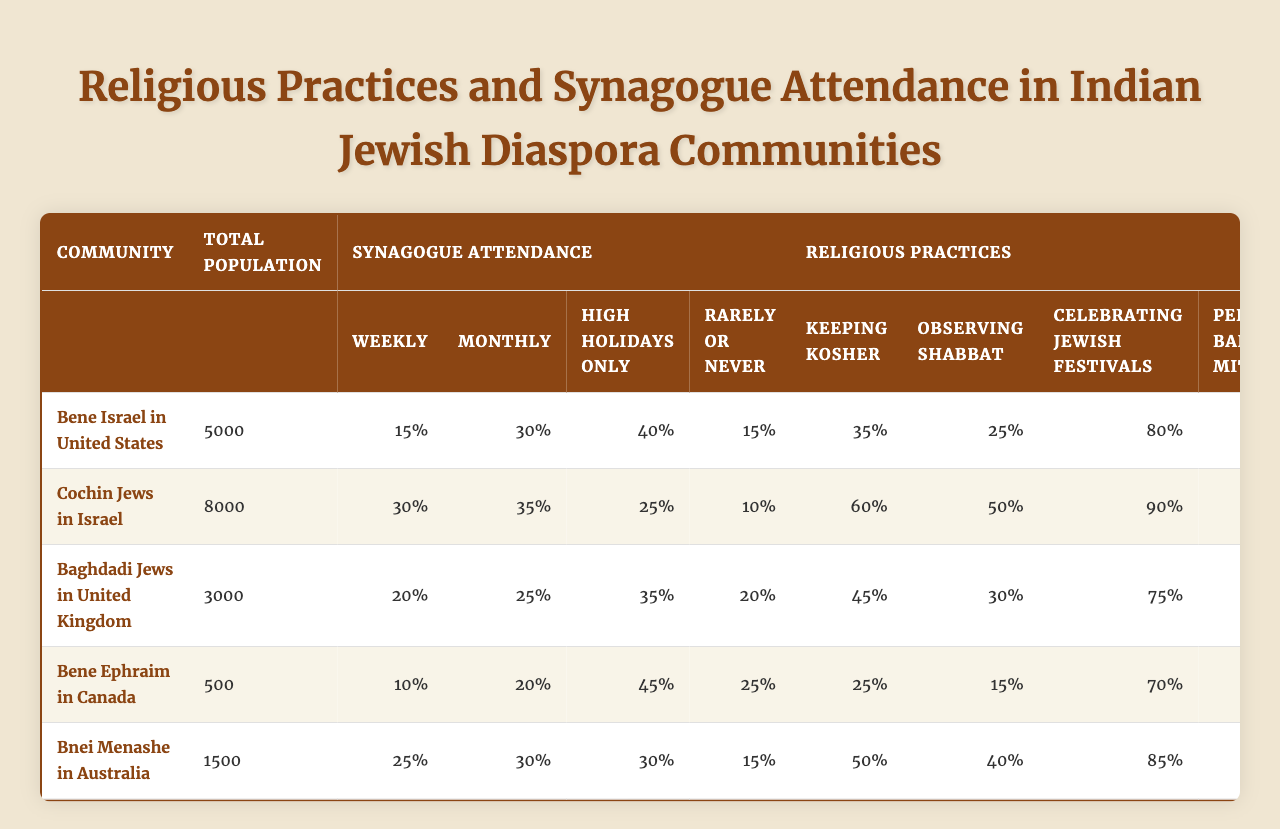What percentage of the Bene Israel community in the US attends synagogue weekly? The table shows that 15% of the Bene Israel community in the United States attends synagogue weekly.
Answer: 15% Which community has the highest percentage of individuals keeping kosher? Among the communities listed, the Cochin Jews in Israel have the highest percentage of individuals keeping kosher, which is 60%.
Answer: 60% What is the combined percentage of the Bnei Menashe community in Australia that attends synagogue weekly or monthly? To find the combined percentage, add the weekly (25%) and monthly (30%) attendance rates: 25% + 30% = 55%.
Answer: 55% Do the Bene Ephraim in Canada have a higher rate of observing Shabbat than the Baghdadi Jews in the UK? The rate of observing Shabbat among the Bene Ephraim is 15%, while it is 30% for the Baghdadi Jews. Therefore, the Bene Ephraim do not have a higher rate of observing Shabbat.
Answer: No What community has the lowest total population, and what is their synagogue attendance rate for High Holidays only? The Bene Ephraim in Canada have the lowest total population, which is 500, and their synagogue attendance rate for High Holidays only is 45%.
Answer: 45% If you sum the percentages of individuals celebrating Jewish festivals among all communities, what is the total? The percentages are as follows: 80% (Bene Israel) + 90% (Cochin Jews) + 75% (Baghdadi Jews) + 70% (Bene Ephraim) + 85% (Bnei Menashe) = 400%.
Answer: 400% Which community performs Bar/Bat Mitzvah at the lowest percentage? The Bene Ephraim community performs Bar/Bat Mitzvah at 50%, which is the lowest percentage among the communities listed.
Answer: 50% Is the synagogue attendance for High Holidays only higher among the Cochin Jews than the Bnei Menashe? The Cochin Jews have a High Holiday attendance rate of 25%, while the Bnei Menashe have a rate of 30%, indicating that the Bnei Menashe have higher attendance for High Holidays.
Answer: Yes What percentage of the Baghdadi Jewish community in the UK attends synagogue rarely or never? According to the table, 20% of the Baghdadi Jewish community in the United Kingdom attends synagogue rarely or never.
Answer: 20% Calculating the average synagogue attendance for the Cochin Jews, what do you get? The average synagogue attendance can be calculated as (30% + 35% + 25% + 10%) / 4 = 25%.
Answer: 25% 